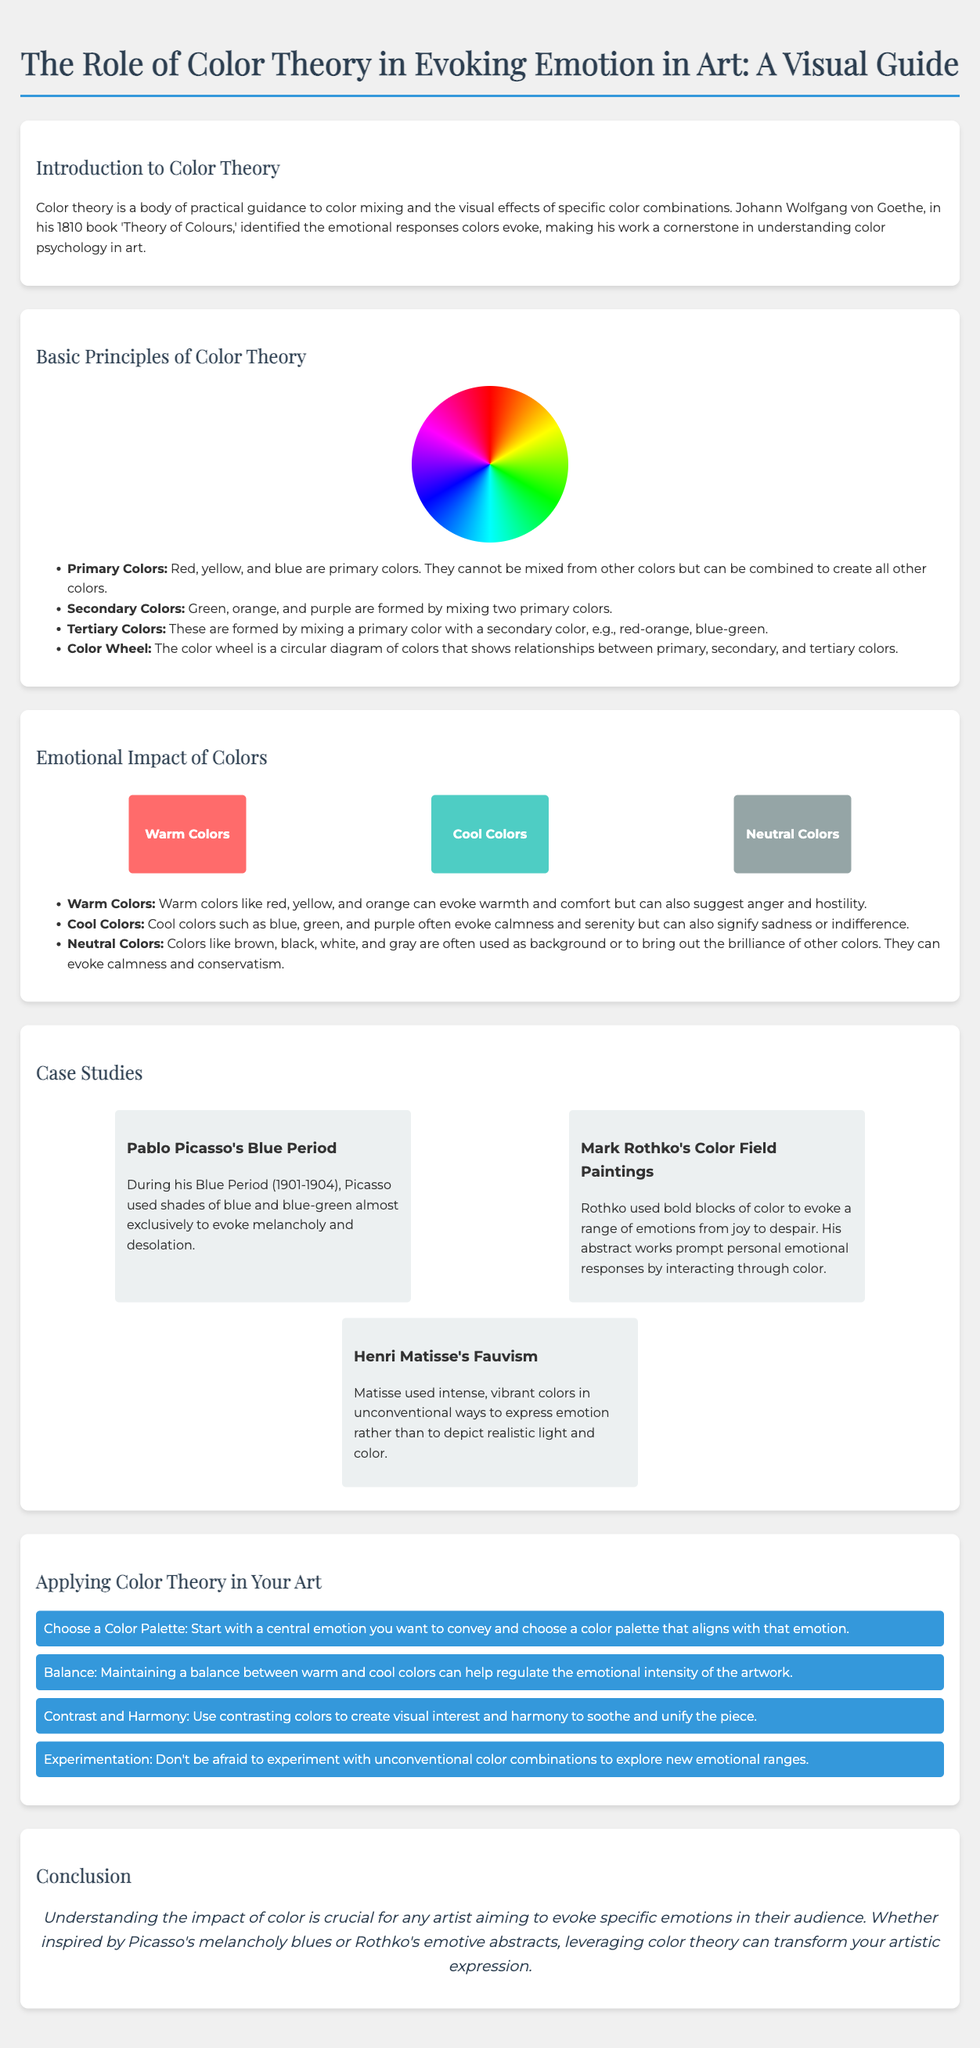what is the title of the infographic? The title is prominently displayed at the top of the document, summarizing the main focus of the infographic.
Answer: The Role of Color Theory in Evoking Emotion in Art: A Visual Guide who identified the emotional responses colors evoke? This person is mentioned in the introduction section of the document as a key figure in color psychology.
Answer: Johann Wolfgang von Goethe what are the primary colors listed? The primary colors are specified in the basic principles section and are foundational to color mixing.
Answer: Red, yellow, and blue what period is associated with Pablo Picasso in the case studies? The specific time frame is provided in the description of his use of color and emotion.
Answer: Blue Period (1901-1904) which type of colors evoke calmness and serenity? The document describes different types of colors under emotional impact, indicating which evoke certain feelings.
Answer: Cool Colors how many case studies are presented? The number of case studies is outlined in the case studies section of the infographic.
Answer: Three what should artists maintain to regulate the emotional intensity of their artwork? This guidance is given in the tips section for applying color theory in art.
Answer: Balance what is the concluding advice for artists? The conclusion emphasizes the importance of understanding color impact in emotional expression.
Answer: Understanding the impact of color is crucial for any artist 